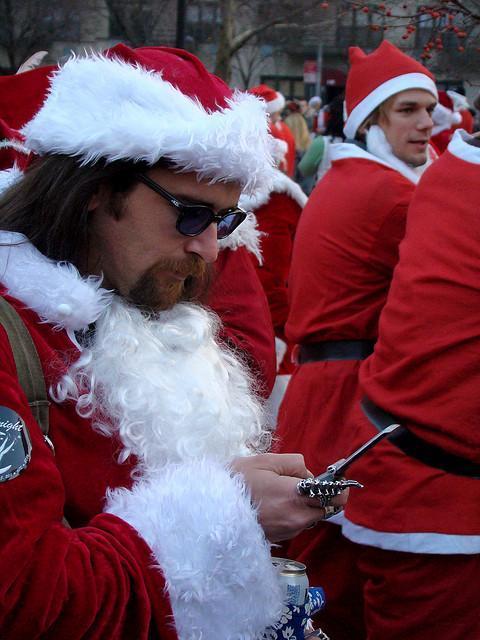How many people are visible?
Give a very brief answer. 4. 